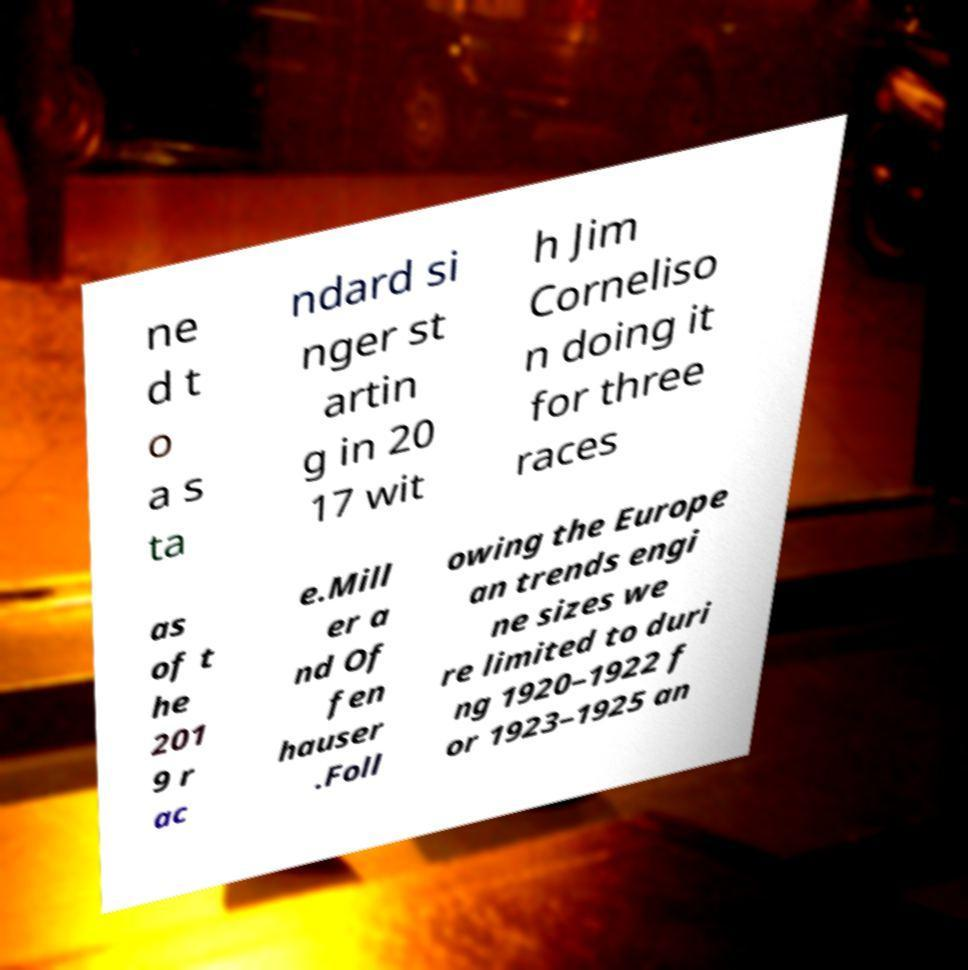Can you accurately transcribe the text from the provided image for me? ne d t o a s ta ndard si nger st artin g in 20 17 wit h Jim Corneliso n doing it for three races as of t he 201 9 r ac e.Mill er a nd Of fen hauser .Foll owing the Europe an trends engi ne sizes we re limited to duri ng 1920–1922 f or 1923–1925 an 